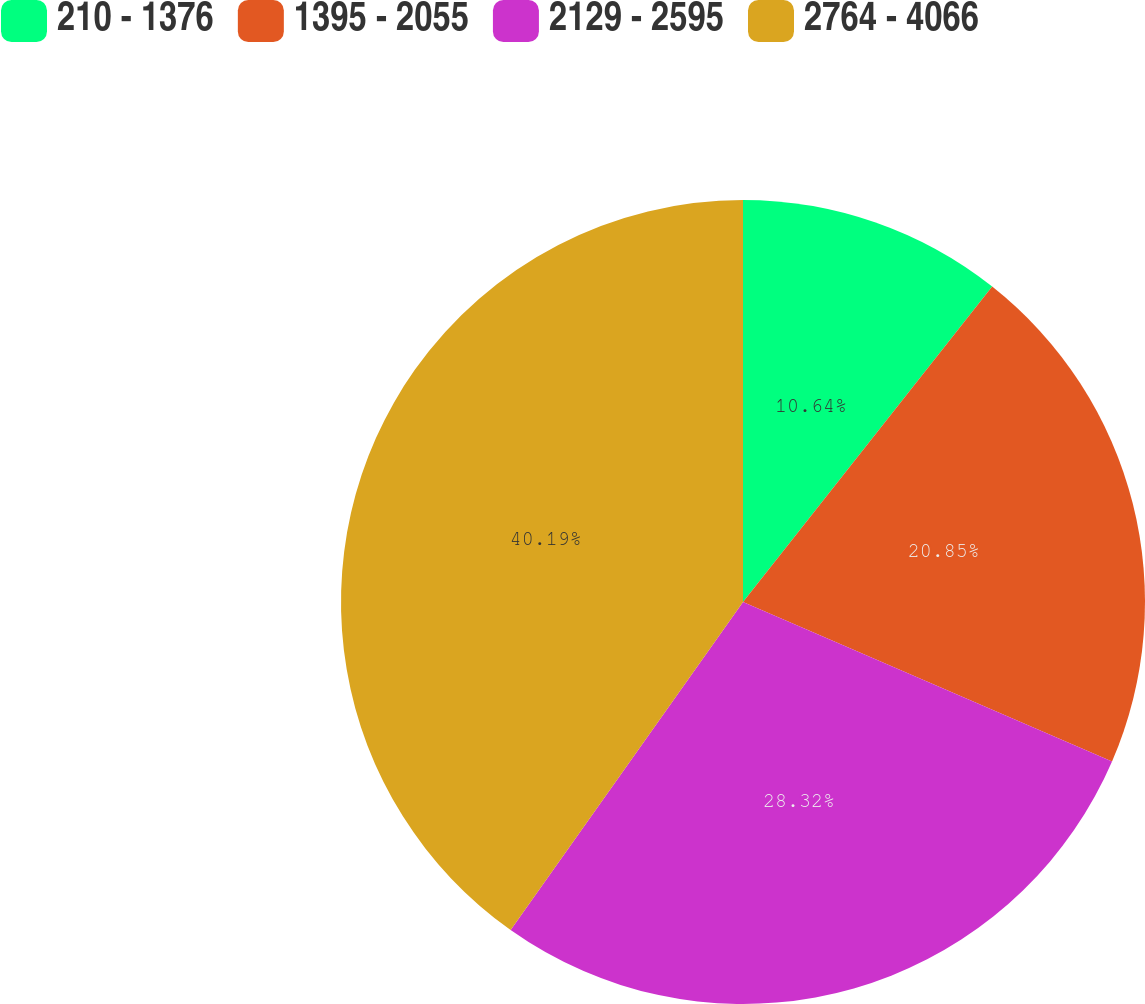Convert chart to OTSL. <chart><loc_0><loc_0><loc_500><loc_500><pie_chart><fcel>210 - 1376<fcel>1395 - 2055<fcel>2129 - 2595<fcel>2764 - 4066<nl><fcel>10.64%<fcel>20.85%<fcel>28.32%<fcel>40.19%<nl></chart> 